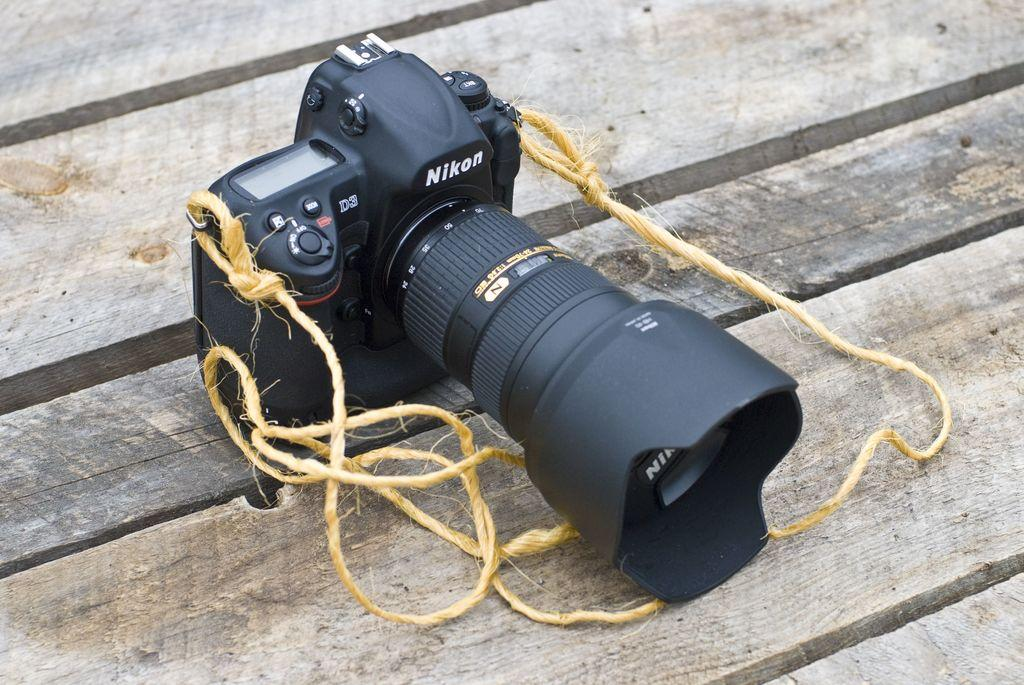What is the main object in the image? There is a camera in the image. How is the camera secured in the image? The camera is tied with ropes to its edges. What is the camera placed on in the image? The camera is on a wooden platform. What type of vegetable is being used to protect the camera from a rainstorm in the image? There is no vegetable present in the image, nor is there any indication of a rainstorm. 